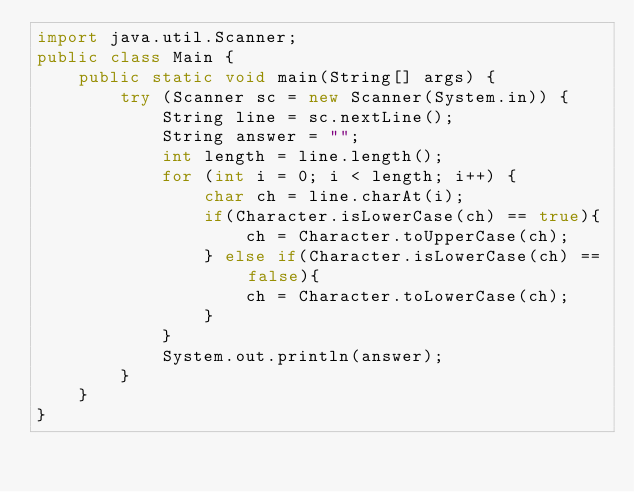<code> <loc_0><loc_0><loc_500><loc_500><_Java_>import java.util.Scanner;
public class Main { 
    public static void main(String[] args) {  
        try (Scanner sc = new Scanner(System.in)) { 
            String line = sc.nextLine(); 
            String answer = ""; 
            int length = line.length(); 
            for (int i = 0; i < length; i++) { 
                char ch = line.charAt(i); 
                if(Character.isLowerCase(ch) == true){
                    ch = Character.toUpperCase(ch);
                } else if(Character.isLowerCase(ch) == false){
                    ch = Character.toLowerCase(ch);
                }
            } 
            System.out.println(answer); 
        } 
    }
}

</code> 